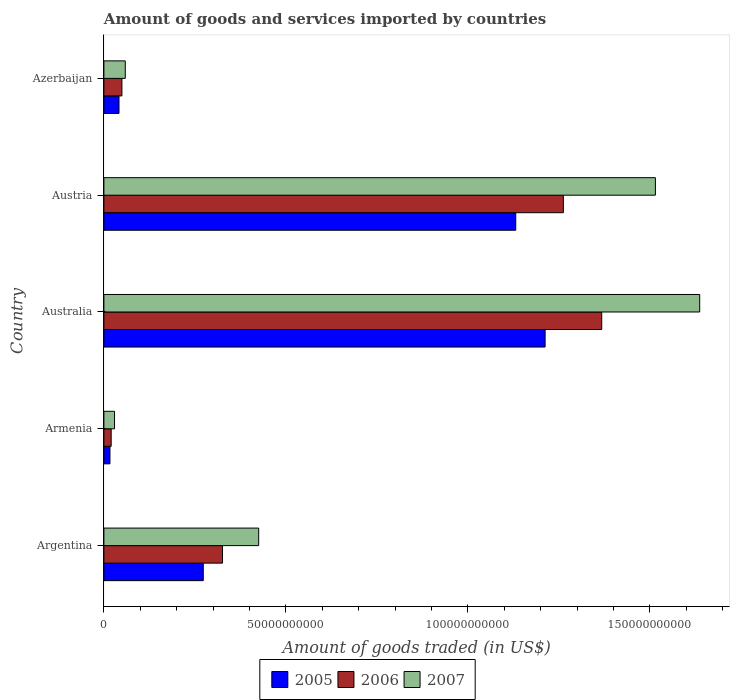How many groups of bars are there?
Make the answer very short. 5. Are the number of bars per tick equal to the number of legend labels?
Give a very brief answer. Yes. How many bars are there on the 2nd tick from the bottom?
Provide a short and direct response. 3. In how many cases, is the number of bars for a given country not equal to the number of legend labels?
Provide a succinct answer. 0. What is the total amount of goods and services imported in 2005 in Azerbaijan?
Your response must be concise. 4.15e+09. Across all countries, what is the maximum total amount of goods and services imported in 2005?
Make the answer very short. 1.21e+11. Across all countries, what is the minimum total amount of goods and services imported in 2005?
Keep it short and to the point. 1.66e+09. In which country was the total amount of goods and services imported in 2006 maximum?
Your answer should be compact. Australia. In which country was the total amount of goods and services imported in 2006 minimum?
Ensure brevity in your answer.  Armenia. What is the total total amount of goods and services imported in 2006 in the graph?
Ensure brevity in your answer.  3.03e+11. What is the difference between the total amount of goods and services imported in 2006 in Argentina and that in Azerbaijan?
Offer a terse response. 2.76e+1. What is the difference between the total amount of goods and services imported in 2006 in Armenia and the total amount of goods and services imported in 2005 in Azerbaijan?
Give a very brief answer. -2.15e+09. What is the average total amount of goods and services imported in 2006 per country?
Make the answer very short. 6.05e+1. What is the difference between the total amount of goods and services imported in 2005 and total amount of goods and services imported in 2006 in Austria?
Provide a short and direct response. -1.31e+1. In how many countries, is the total amount of goods and services imported in 2006 greater than 20000000000 US$?
Provide a succinct answer. 3. What is the ratio of the total amount of goods and services imported in 2006 in Argentina to that in Armenia?
Give a very brief answer. 16.29. Is the total amount of goods and services imported in 2006 in Armenia less than that in Austria?
Give a very brief answer. Yes. What is the difference between the highest and the second highest total amount of goods and services imported in 2007?
Offer a terse response. 1.22e+1. What is the difference between the highest and the lowest total amount of goods and services imported in 2005?
Keep it short and to the point. 1.20e+11. What does the 1st bar from the top in Armenia represents?
Your answer should be very brief. 2007. What does the 3rd bar from the bottom in Azerbaijan represents?
Provide a short and direct response. 2007. How many bars are there?
Your answer should be very brief. 15. Are all the bars in the graph horizontal?
Ensure brevity in your answer.  Yes. How many countries are there in the graph?
Ensure brevity in your answer.  5. Does the graph contain any zero values?
Offer a very short reply. No. What is the title of the graph?
Make the answer very short. Amount of goods and services imported by countries. Does "1991" appear as one of the legend labels in the graph?
Provide a short and direct response. No. What is the label or title of the X-axis?
Keep it short and to the point. Amount of goods traded (in US$). What is the Amount of goods traded (in US$) in 2005 in Argentina?
Provide a short and direct response. 2.73e+1. What is the Amount of goods traded (in US$) in 2006 in Argentina?
Ensure brevity in your answer.  3.26e+1. What is the Amount of goods traded (in US$) of 2007 in Argentina?
Make the answer very short. 4.25e+1. What is the Amount of goods traded (in US$) in 2005 in Armenia?
Offer a terse response. 1.66e+09. What is the Amount of goods traded (in US$) in 2006 in Armenia?
Make the answer very short. 2.00e+09. What is the Amount of goods traded (in US$) of 2007 in Armenia?
Provide a succinct answer. 2.92e+09. What is the Amount of goods traded (in US$) of 2005 in Australia?
Your answer should be compact. 1.21e+11. What is the Amount of goods traded (in US$) in 2006 in Australia?
Provide a short and direct response. 1.37e+11. What is the Amount of goods traded (in US$) of 2007 in Australia?
Make the answer very short. 1.64e+11. What is the Amount of goods traded (in US$) of 2005 in Austria?
Ensure brevity in your answer.  1.13e+11. What is the Amount of goods traded (in US$) of 2006 in Austria?
Your answer should be very brief. 1.26e+11. What is the Amount of goods traded (in US$) in 2007 in Austria?
Offer a very short reply. 1.52e+11. What is the Amount of goods traded (in US$) in 2005 in Azerbaijan?
Make the answer very short. 4.15e+09. What is the Amount of goods traded (in US$) of 2006 in Azerbaijan?
Provide a short and direct response. 4.95e+09. What is the Amount of goods traded (in US$) in 2007 in Azerbaijan?
Offer a terse response. 5.88e+09. Across all countries, what is the maximum Amount of goods traded (in US$) in 2005?
Give a very brief answer. 1.21e+11. Across all countries, what is the maximum Amount of goods traded (in US$) in 2006?
Ensure brevity in your answer.  1.37e+11. Across all countries, what is the maximum Amount of goods traded (in US$) in 2007?
Your response must be concise. 1.64e+11. Across all countries, what is the minimum Amount of goods traded (in US$) in 2005?
Provide a short and direct response. 1.66e+09. Across all countries, what is the minimum Amount of goods traded (in US$) of 2006?
Keep it short and to the point. 2.00e+09. Across all countries, what is the minimum Amount of goods traded (in US$) in 2007?
Ensure brevity in your answer.  2.92e+09. What is the total Amount of goods traded (in US$) of 2005 in the graph?
Offer a very short reply. 2.67e+11. What is the total Amount of goods traded (in US$) in 2006 in the graph?
Give a very brief answer. 3.03e+11. What is the total Amount of goods traded (in US$) in 2007 in the graph?
Make the answer very short. 3.67e+11. What is the difference between the Amount of goods traded (in US$) of 2005 in Argentina and that in Armenia?
Give a very brief answer. 2.56e+1. What is the difference between the Amount of goods traded (in US$) in 2006 in Argentina and that in Armenia?
Keep it short and to the point. 3.06e+1. What is the difference between the Amount of goods traded (in US$) of 2007 in Argentina and that in Armenia?
Provide a short and direct response. 3.96e+1. What is the difference between the Amount of goods traded (in US$) of 2005 in Argentina and that in Australia?
Keep it short and to the point. -9.39e+1. What is the difference between the Amount of goods traded (in US$) in 2006 in Argentina and that in Australia?
Ensure brevity in your answer.  -1.04e+11. What is the difference between the Amount of goods traded (in US$) in 2007 in Argentina and that in Australia?
Your answer should be compact. -1.21e+11. What is the difference between the Amount of goods traded (in US$) in 2005 in Argentina and that in Austria?
Make the answer very short. -8.58e+1. What is the difference between the Amount of goods traded (in US$) of 2006 in Argentina and that in Austria?
Make the answer very short. -9.36e+1. What is the difference between the Amount of goods traded (in US$) in 2007 in Argentina and that in Austria?
Ensure brevity in your answer.  -1.09e+11. What is the difference between the Amount of goods traded (in US$) of 2005 in Argentina and that in Azerbaijan?
Provide a short and direct response. 2.31e+1. What is the difference between the Amount of goods traded (in US$) of 2006 in Argentina and that in Azerbaijan?
Provide a short and direct response. 2.76e+1. What is the difference between the Amount of goods traded (in US$) of 2007 in Argentina and that in Azerbaijan?
Keep it short and to the point. 3.66e+1. What is the difference between the Amount of goods traded (in US$) in 2005 in Armenia and that in Australia?
Give a very brief answer. -1.20e+11. What is the difference between the Amount of goods traded (in US$) in 2006 in Armenia and that in Australia?
Keep it short and to the point. -1.35e+11. What is the difference between the Amount of goods traded (in US$) of 2007 in Armenia and that in Australia?
Keep it short and to the point. -1.61e+11. What is the difference between the Amount of goods traded (in US$) of 2005 in Armenia and that in Austria?
Your answer should be very brief. -1.11e+11. What is the difference between the Amount of goods traded (in US$) of 2006 in Armenia and that in Austria?
Ensure brevity in your answer.  -1.24e+11. What is the difference between the Amount of goods traded (in US$) of 2007 in Armenia and that in Austria?
Provide a succinct answer. -1.49e+11. What is the difference between the Amount of goods traded (in US$) of 2005 in Armenia and that in Azerbaijan?
Provide a succinct answer. -2.49e+09. What is the difference between the Amount of goods traded (in US$) of 2006 in Armenia and that in Azerbaijan?
Provide a succinct answer. -2.95e+09. What is the difference between the Amount of goods traded (in US$) of 2007 in Armenia and that in Azerbaijan?
Provide a short and direct response. -2.96e+09. What is the difference between the Amount of goods traded (in US$) in 2005 in Australia and that in Austria?
Your answer should be very brief. 8.06e+09. What is the difference between the Amount of goods traded (in US$) in 2006 in Australia and that in Austria?
Provide a short and direct response. 1.05e+1. What is the difference between the Amount of goods traded (in US$) of 2007 in Australia and that in Austria?
Your answer should be compact. 1.22e+1. What is the difference between the Amount of goods traded (in US$) in 2005 in Australia and that in Azerbaijan?
Provide a succinct answer. 1.17e+11. What is the difference between the Amount of goods traded (in US$) of 2006 in Australia and that in Azerbaijan?
Make the answer very short. 1.32e+11. What is the difference between the Amount of goods traded (in US$) in 2007 in Australia and that in Azerbaijan?
Keep it short and to the point. 1.58e+11. What is the difference between the Amount of goods traded (in US$) of 2005 in Austria and that in Azerbaijan?
Offer a terse response. 1.09e+11. What is the difference between the Amount of goods traded (in US$) in 2006 in Austria and that in Azerbaijan?
Keep it short and to the point. 1.21e+11. What is the difference between the Amount of goods traded (in US$) in 2007 in Austria and that in Azerbaijan?
Offer a very short reply. 1.46e+11. What is the difference between the Amount of goods traded (in US$) of 2005 in Argentina and the Amount of goods traded (in US$) of 2006 in Armenia?
Keep it short and to the point. 2.53e+1. What is the difference between the Amount of goods traded (in US$) of 2005 in Argentina and the Amount of goods traded (in US$) of 2007 in Armenia?
Your answer should be compact. 2.44e+1. What is the difference between the Amount of goods traded (in US$) in 2006 in Argentina and the Amount of goods traded (in US$) in 2007 in Armenia?
Give a very brief answer. 2.97e+1. What is the difference between the Amount of goods traded (in US$) in 2005 in Argentina and the Amount of goods traded (in US$) in 2006 in Australia?
Offer a very short reply. -1.09e+11. What is the difference between the Amount of goods traded (in US$) in 2005 in Argentina and the Amount of goods traded (in US$) in 2007 in Australia?
Provide a short and direct response. -1.36e+11. What is the difference between the Amount of goods traded (in US$) of 2006 in Argentina and the Amount of goods traded (in US$) of 2007 in Australia?
Provide a short and direct response. -1.31e+11. What is the difference between the Amount of goods traded (in US$) in 2005 in Argentina and the Amount of goods traded (in US$) in 2006 in Austria?
Keep it short and to the point. -9.89e+1. What is the difference between the Amount of goods traded (in US$) in 2005 in Argentina and the Amount of goods traded (in US$) in 2007 in Austria?
Provide a short and direct response. -1.24e+11. What is the difference between the Amount of goods traded (in US$) in 2006 in Argentina and the Amount of goods traded (in US$) in 2007 in Austria?
Give a very brief answer. -1.19e+11. What is the difference between the Amount of goods traded (in US$) in 2005 in Argentina and the Amount of goods traded (in US$) in 2006 in Azerbaijan?
Your answer should be compact. 2.23e+1. What is the difference between the Amount of goods traded (in US$) in 2005 in Argentina and the Amount of goods traded (in US$) in 2007 in Azerbaijan?
Your response must be concise. 2.14e+1. What is the difference between the Amount of goods traded (in US$) in 2006 in Argentina and the Amount of goods traded (in US$) in 2007 in Azerbaijan?
Your response must be concise. 2.67e+1. What is the difference between the Amount of goods traded (in US$) of 2005 in Armenia and the Amount of goods traded (in US$) of 2006 in Australia?
Give a very brief answer. -1.35e+11. What is the difference between the Amount of goods traded (in US$) in 2005 in Armenia and the Amount of goods traded (in US$) in 2007 in Australia?
Provide a succinct answer. -1.62e+11. What is the difference between the Amount of goods traded (in US$) of 2006 in Armenia and the Amount of goods traded (in US$) of 2007 in Australia?
Your response must be concise. -1.62e+11. What is the difference between the Amount of goods traded (in US$) in 2005 in Armenia and the Amount of goods traded (in US$) in 2006 in Austria?
Provide a succinct answer. -1.25e+11. What is the difference between the Amount of goods traded (in US$) of 2005 in Armenia and the Amount of goods traded (in US$) of 2007 in Austria?
Your response must be concise. -1.50e+11. What is the difference between the Amount of goods traded (in US$) of 2006 in Armenia and the Amount of goods traded (in US$) of 2007 in Austria?
Offer a very short reply. -1.50e+11. What is the difference between the Amount of goods traded (in US$) in 2005 in Armenia and the Amount of goods traded (in US$) in 2006 in Azerbaijan?
Make the answer very short. -3.29e+09. What is the difference between the Amount of goods traded (in US$) of 2005 in Armenia and the Amount of goods traded (in US$) of 2007 in Azerbaijan?
Offer a very short reply. -4.21e+09. What is the difference between the Amount of goods traded (in US$) of 2006 in Armenia and the Amount of goods traded (in US$) of 2007 in Azerbaijan?
Ensure brevity in your answer.  -3.88e+09. What is the difference between the Amount of goods traded (in US$) in 2005 in Australia and the Amount of goods traded (in US$) in 2006 in Austria?
Make the answer very short. -5.01e+09. What is the difference between the Amount of goods traded (in US$) in 2005 in Australia and the Amount of goods traded (in US$) in 2007 in Austria?
Your response must be concise. -3.03e+1. What is the difference between the Amount of goods traded (in US$) in 2006 in Australia and the Amount of goods traded (in US$) in 2007 in Austria?
Make the answer very short. -1.47e+1. What is the difference between the Amount of goods traded (in US$) in 2005 in Australia and the Amount of goods traded (in US$) in 2006 in Azerbaijan?
Your response must be concise. 1.16e+11. What is the difference between the Amount of goods traded (in US$) in 2005 in Australia and the Amount of goods traded (in US$) in 2007 in Azerbaijan?
Give a very brief answer. 1.15e+11. What is the difference between the Amount of goods traded (in US$) of 2006 in Australia and the Amount of goods traded (in US$) of 2007 in Azerbaijan?
Offer a very short reply. 1.31e+11. What is the difference between the Amount of goods traded (in US$) in 2005 in Austria and the Amount of goods traded (in US$) in 2006 in Azerbaijan?
Ensure brevity in your answer.  1.08e+11. What is the difference between the Amount of goods traded (in US$) in 2005 in Austria and the Amount of goods traded (in US$) in 2007 in Azerbaijan?
Your response must be concise. 1.07e+11. What is the difference between the Amount of goods traded (in US$) of 2006 in Austria and the Amount of goods traded (in US$) of 2007 in Azerbaijan?
Your response must be concise. 1.20e+11. What is the average Amount of goods traded (in US$) of 2005 per country?
Your answer should be compact. 5.35e+1. What is the average Amount of goods traded (in US$) of 2006 per country?
Give a very brief answer. 6.05e+1. What is the average Amount of goods traded (in US$) of 2007 per country?
Make the answer very short. 7.33e+1. What is the difference between the Amount of goods traded (in US$) in 2005 and Amount of goods traded (in US$) in 2006 in Argentina?
Make the answer very short. -5.29e+09. What is the difference between the Amount of goods traded (in US$) of 2005 and Amount of goods traded (in US$) of 2007 in Argentina?
Your response must be concise. -1.52e+1. What is the difference between the Amount of goods traded (in US$) in 2006 and Amount of goods traded (in US$) in 2007 in Argentina?
Make the answer very short. -9.94e+09. What is the difference between the Amount of goods traded (in US$) of 2005 and Amount of goods traded (in US$) of 2006 in Armenia?
Keep it short and to the point. -3.37e+08. What is the difference between the Amount of goods traded (in US$) in 2005 and Amount of goods traded (in US$) in 2007 in Armenia?
Your answer should be very brief. -1.26e+09. What is the difference between the Amount of goods traded (in US$) of 2006 and Amount of goods traded (in US$) of 2007 in Armenia?
Make the answer very short. -9.21e+08. What is the difference between the Amount of goods traded (in US$) in 2005 and Amount of goods traded (in US$) in 2006 in Australia?
Offer a terse response. -1.56e+1. What is the difference between the Amount of goods traded (in US$) in 2005 and Amount of goods traded (in US$) in 2007 in Australia?
Give a very brief answer. -4.25e+1. What is the difference between the Amount of goods traded (in US$) of 2006 and Amount of goods traded (in US$) of 2007 in Australia?
Provide a succinct answer. -2.69e+1. What is the difference between the Amount of goods traded (in US$) of 2005 and Amount of goods traded (in US$) of 2006 in Austria?
Provide a succinct answer. -1.31e+1. What is the difference between the Amount of goods traded (in US$) of 2005 and Amount of goods traded (in US$) of 2007 in Austria?
Your answer should be very brief. -3.84e+1. What is the difference between the Amount of goods traded (in US$) of 2006 and Amount of goods traded (in US$) of 2007 in Austria?
Offer a terse response. -2.53e+1. What is the difference between the Amount of goods traded (in US$) of 2005 and Amount of goods traded (in US$) of 2006 in Azerbaijan?
Ensure brevity in your answer.  -8.02e+08. What is the difference between the Amount of goods traded (in US$) in 2005 and Amount of goods traded (in US$) in 2007 in Azerbaijan?
Provide a succinct answer. -1.73e+09. What is the difference between the Amount of goods traded (in US$) in 2006 and Amount of goods traded (in US$) in 2007 in Azerbaijan?
Offer a very short reply. -9.23e+08. What is the ratio of the Amount of goods traded (in US$) of 2005 in Argentina to that in Armenia?
Keep it short and to the point. 16.41. What is the ratio of the Amount of goods traded (in US$) of 2006 in Argentina to that in Armenia?
Your answer should be compact. 16.29. What is the ratio of the Amount of goods traded (in US$) in 2007 in Argentina to that in Armenia?
Ensure brevity in your answer.  14.56. What is the ratio of the Amount of goods traded (in US$) in 2005 in Argentina to that in Australia?
Offer a terse response. 0.23. What is the ratio of the Amount of goods traded (in US$) in 2006 in Argentina to that in Australia?
Keep it short and to the point. 0.24. What is the ratio of the Amount of goods traded (in US$) in 2007 in Argentina to that in Australia?
Make the answer very short. 0.26. What is the ratio of the Amount of goods traded (in US$) of 2005 in Argentina to that in Austria?
Offer a very short reply. 0.24. What is the ratio of the Amount of goods traded (in US$) of 2006 in Argentina to that in Austria?
Your response must be concise. 0.26. What is the ratio of the Amount of goods traded (in US$) of 2007 in Argentina to that in Austria?
Your answer should be compact. 0.28. What is the ratio of the Amount of goods traded (in US$) in 2005 in Argentina to that in Azerbaijan?
Offer a very short reply. 6.58. What is the ratio of the Amount of goods traded (in US$) in 2006 in Argentina to that in Azerbaijan?
Your answer should be compact. 6.58. What is the ratio of the Amount of goods traded (in US$) in 2007 in Argentina to that in Azerbaijan?
Provide a succinct answer. 7.24. What is the ratio of the Amount of goods traded (in US$) in 2005 in Armenia to that in Australia?
Make the answer very short. 0.01. What is the ratio of the Amount of goods traded (in US$) in 2006 in Armenia to that in Australia?
Keep it short and to the point. 0.01. What is the ratio of the Amount of goods traded (in US$) in 2007 in Armenia to that in Australia?
Your answer should be very brief. 0.02. What is the ratio of the Amount of goods traded (in US$) in 2005 in Armenia to that in Austria?
Keep it short and to the point. 0.01. What is the ratio of the Amount of goods traded (in US$) of 2006 in Armenia to that in Austria?
Your response must be concise. 0.02. What is the ratio of the Amount of goods traded (in US$) of 2007 in Armenia to that in Austria?
Keep it short and to the point. 0.02. What is the ratio of the Amount of goods traded (in US$) in 2005 in Armenia to that in Azerbaijan?
Offer a terse response. 0.4. What is the ratio of the Amount of goods traded (in US$) of 2006 in Armenia to that in Azerbaijan?
Your answer should be compact. 0.4. What is the ratio of the Amount of goods traded (in US$) in 2007 in Armenia to that in Azerbaijan?
Provide a succinct answer. 0.5. What is the ratio of the Amount of goods traded (in US$) of 2005 in Australia to that in Austria?
Offer a terse response. 1.07. What is the ratio of the Amount of goods traded (in US$) in 2006 in Australia to that in Austria?
Provide a succinct answer. 1.08. What is the ratio of the Amount of goods traded (in US$) of 2007 in Australia to that in Austria?
Provide a short and direct response. 1.08. What is the ratio of the Amount of goods traded (in US$) in 2005 in Australia to that in Azerbaijan?
Give a very brief answer. 29.19. What is the ratio of the Amount of goods traded (in US$) in 2006 in Australia to that in Azerbaijan?
Your response must be concise. 27.61. What is the ratio of the Amount of goods traded (in US$) of 2007 in Australia to that in Azerbaijan?
Give a very brief answer. 27.85. What is the ratio of the Amount of goods traded (in US$) of 2005 in Austria to that in Azerbaijan?
Make the answer very short. 27.25. What is the ratio of the Amount of goods traded (in US$) of 2006 in Austria to that in Azerbaijan?
Ensure brevity in your answer.  25.48. What is the ratio of the Amount of goods traded (in US$) of 2007 in Austria to that in Azerbaijan?
Your answer should be compact. 25.78. What is the difference between the highest and the second highest Amount of goods traded (in US$) of 2005?
Provide a short and direct response. 8.06e+09. What is the difference between the highest and the second highest Amount of goods traded (in US$) of 2006?
Offer a very short reply. 1.05e+1. What is the difference between the highest and the second highest Amount of goods traded (in US$) in 2007?
Give a very brief answer. 1.22e+1. What is the difference between the highest and the lowest Amount of goods traded (in US$) of 2005?
Offer a terse response. 1.20e+11. What is the difference between the highest and the lowest Amount of goods traded (in US$) of 2006?
Offer a terse response. 1.35e+11. What is the difference between the highest and the lowest Amount of goods traded (in US$) of 2007?
Give a very brief answer. 1.61e+11. 